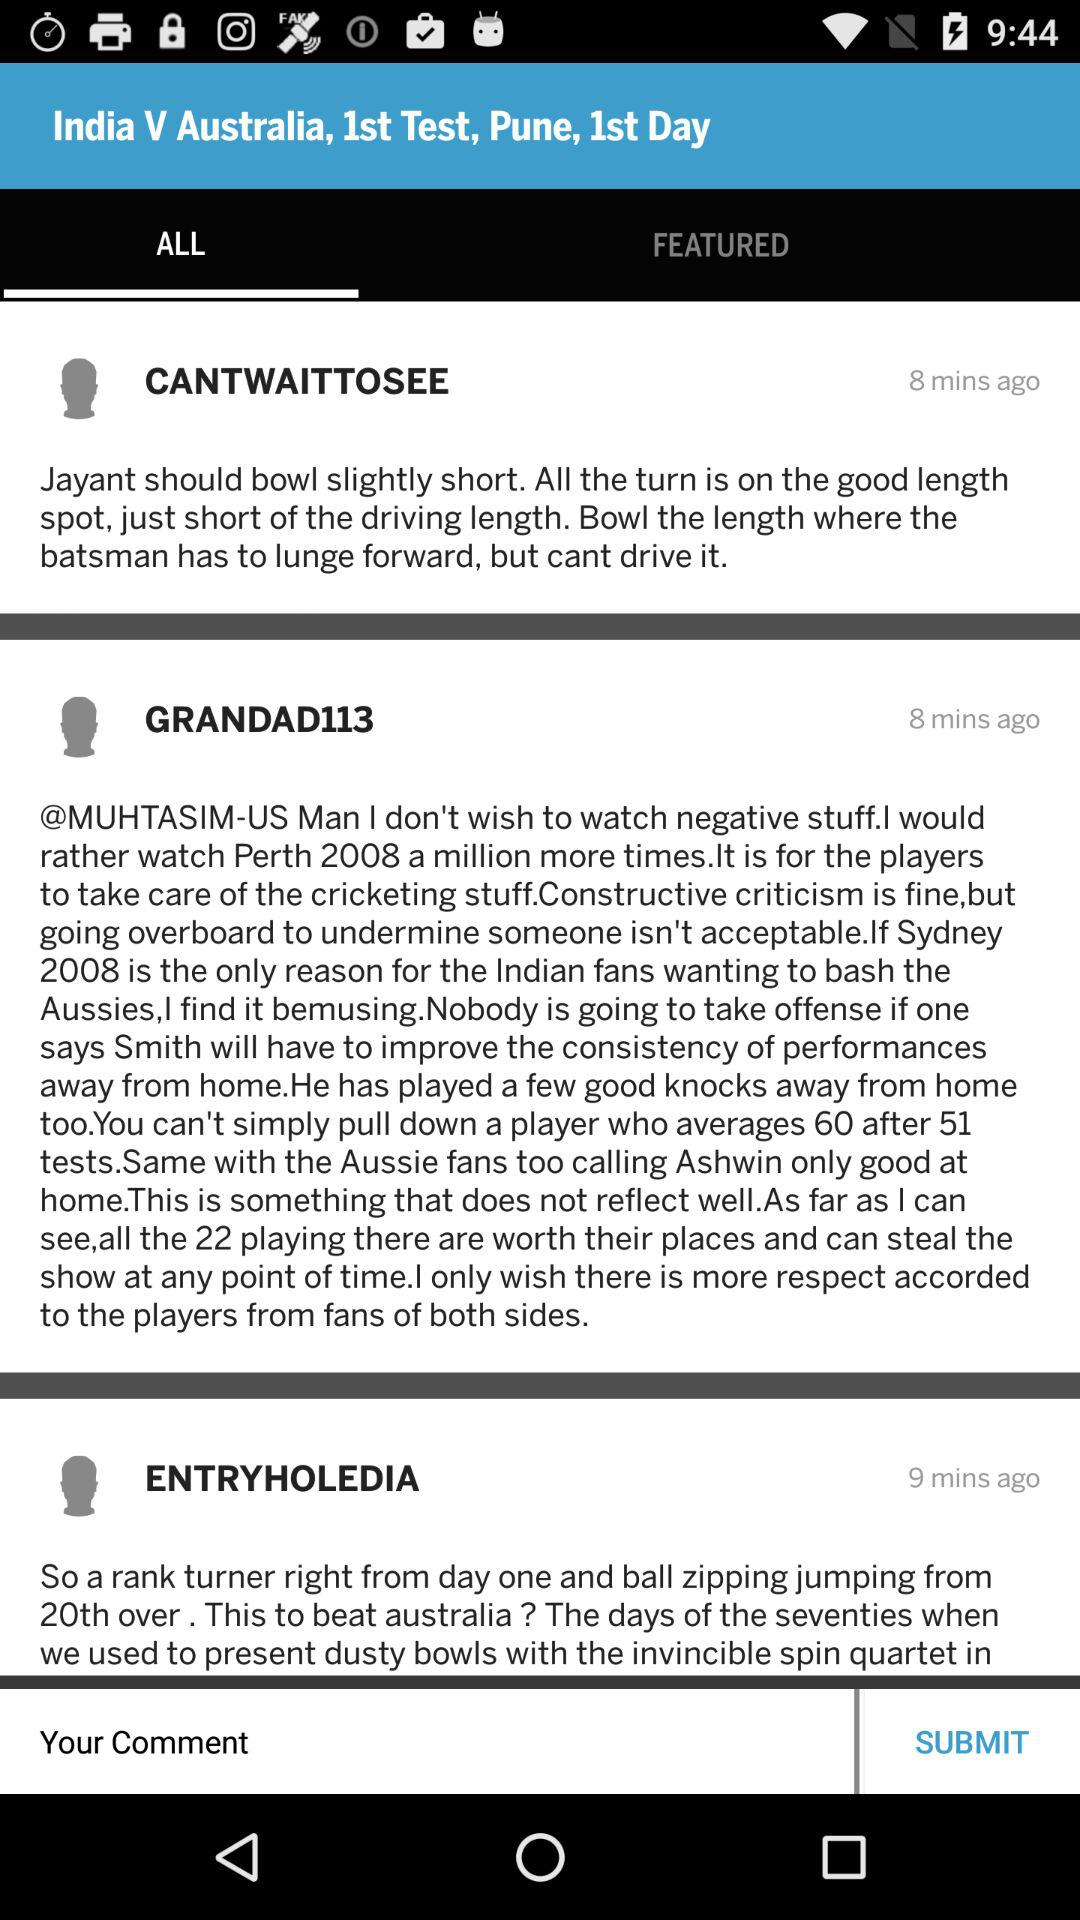What is the first test's location? The location is Pune. 